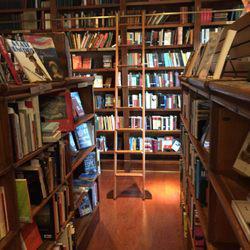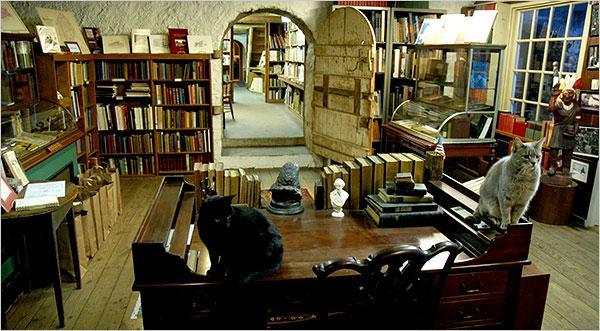The first image is the image on the left, the second image is the image on the right. Assess this claim about the two images: "The left image shows people standing on the left and right of a counter, with heads bent toward each other.". Correct or not? Answer yes or no. No. The first image is the image on the left, the second image is the image on the right. Evaluate the accuracy of this statement regarding the images: "In at least one image there is a female with long hair at the the cash register and at least three customers throughout the bookstore.". Is it true? Answer yes or no. No. 